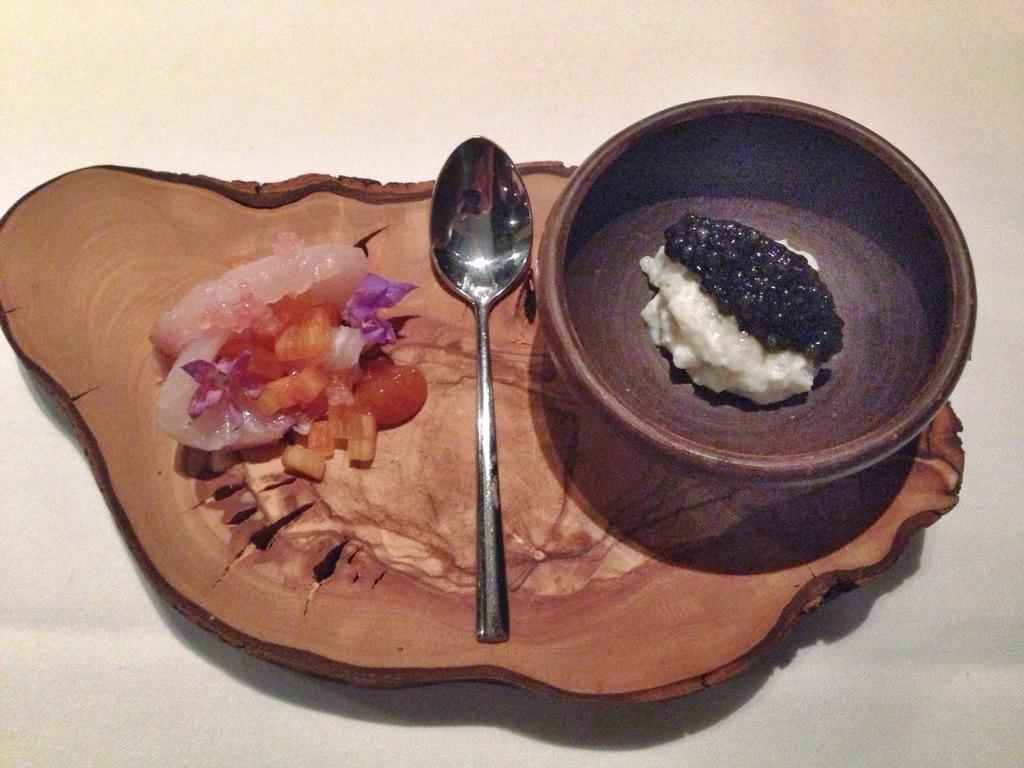What is on the white surface in the image? There is a wooden tray on a white surface. What is on the wooden tray? There is a salad and a bowl with white and black food items on the tray. What utensil is present on the tray? There is a spoon on the tray. Where is the grandmother sitting on the swing in the image? There is no grandmother or swing present in the image. What type of pets can be seen playing with the food items in the image? There are no pets present in the image; it only features a wooden tray with a salad, a bowl, and a spoon. 